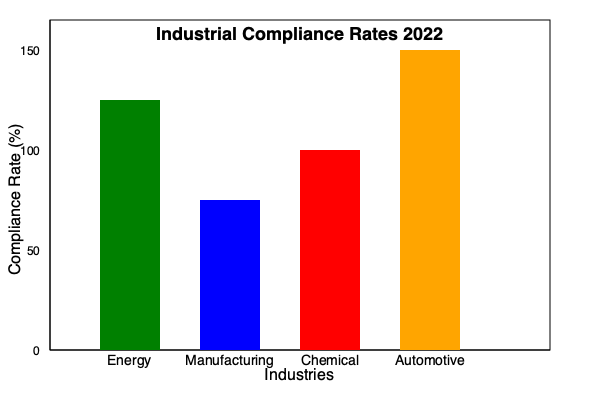Based on the bar graph showing industrial compliance rates for 2022, which industry has the highest compliance rate, and what is the approximate percentage difference between the highest and lowest compliance rates? To answer this question, we need to follow these steps:

1. Identify the highest bar in the graph:
   The orange bar representing the Automotive industry is the tallest.

2. Identify the lowest bar in the graph:
   The blue bar representing the Manufacturing industry is the shortest.

3. Estimate the compliance rates:
   Automotive (orange): Approximately 150%
   Manufacturing (blue): Approximately 75%

4. Calculate the difference:
   $150\% - 75\% = 75\%$

Therefore, the Automotive industry has the highest compliance rate, and the approximate percentage difference between the highest (Automotive) and lowest (Manufacturing) compliance rates is 75%.
Answer: Automotive; 75% 